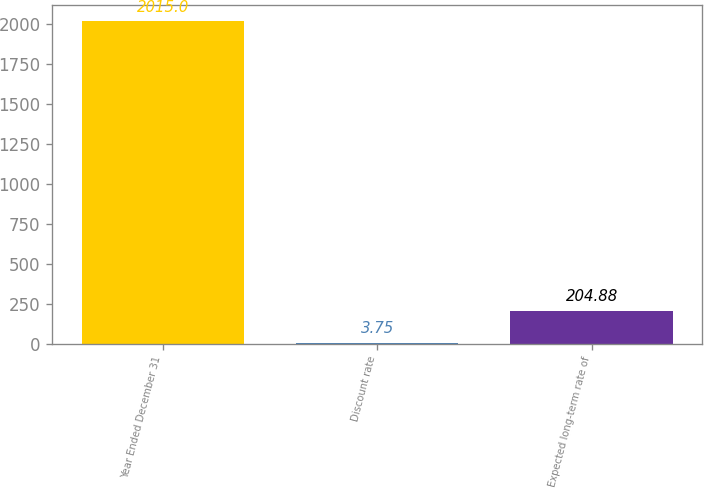Convert chart. <chart><loc_0><loc_0><loc_500><loc_500><bar_chart><fcel>Year Ended December 31<fcel>Discount rate<fcel>Expected long-term rate of<nl><fcel>2015<fcel>3.75<fcel>204.88<nl></chart> 